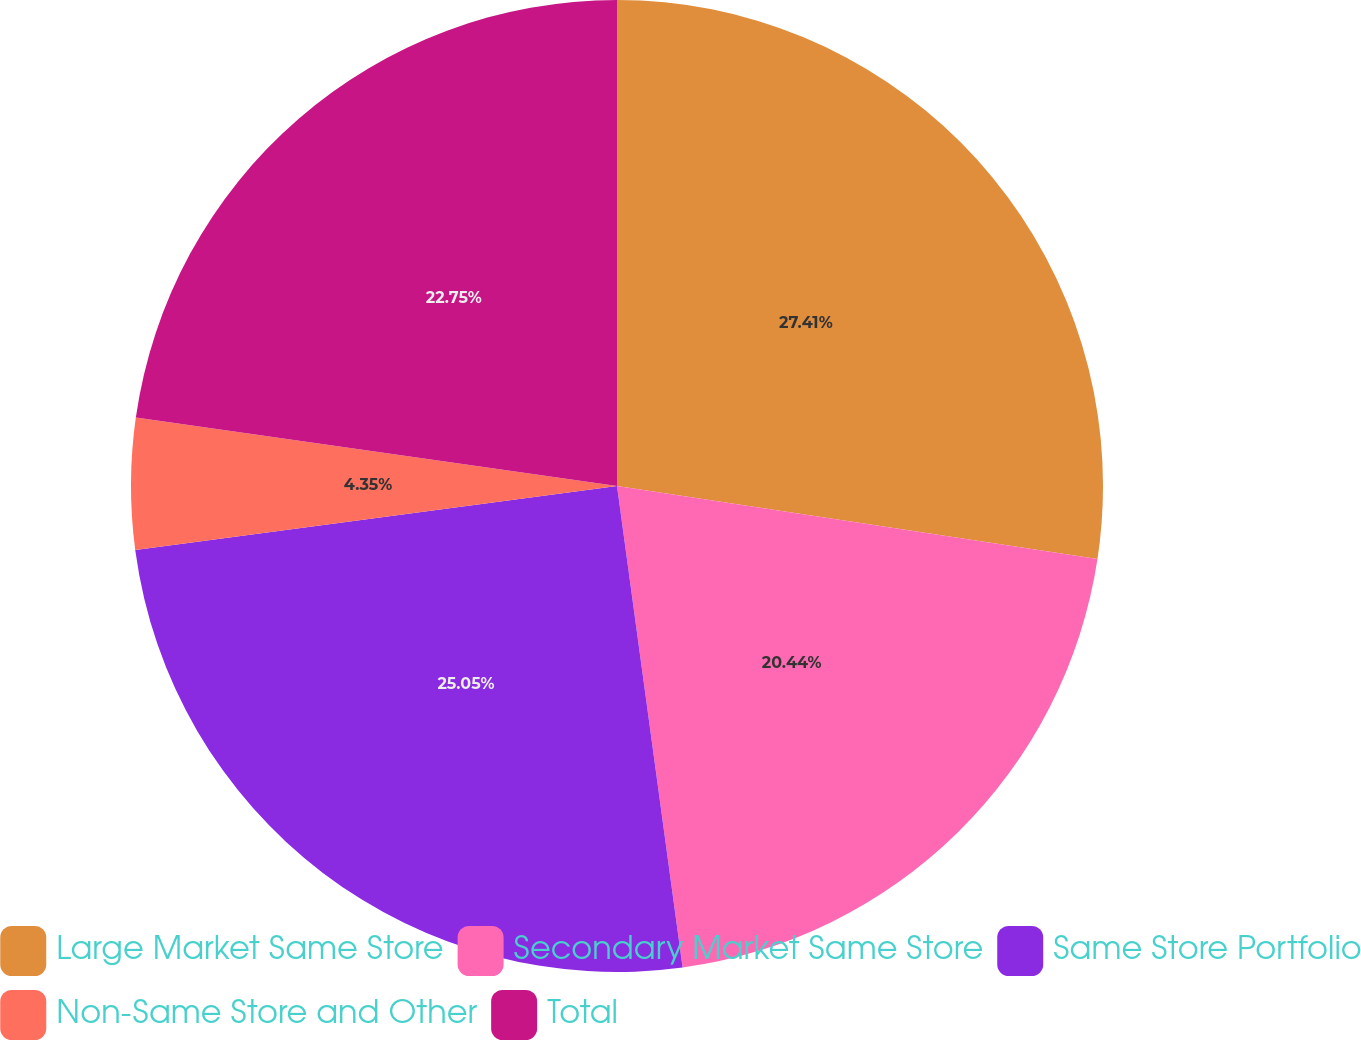Convert chart. <chart><loc_0><loc_0><loc_500><loc_500><pie_chart><fcel>Large Market Same Store<fcel>Secondary Market Same Store<fcel>Same Store Portfolio<fcel>Non-Same Store and Other<fcel>Total<nl><fcel>27.4%<fcel>20.44%<fcel>25.05%<fcel>4.35%<fcel>22.75%<nl></chart> 